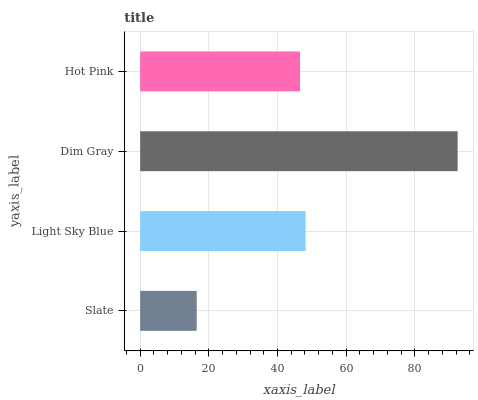Is Slate the minimum?
Answer yes or no. Yes. Is Dim Gray the maximum?
Answer yes or no. Yes. Is Light Sky Blue the minimum?
Answer yes or no. No. Is Light Sky Blue the maximum?
Answer yes or no. No. Is Light Sky Blue greater than Slate?
Answer yes or no. Yes. Is Slate less than Light Sky Blue?
Answer yes or no. Yes. Is Slate greater than Light Sky Blue?
Answer yes or no. No. Is Light Sky Blue less than Slate?
Answer yes or no. No. Is Light Sky Blue the high median?
Answer yes or no. Yes. Is Hot Pink the low median?
Answer yes or no. Yes. Is Dim Gray the high median?
Answer yes or no. No. Is Slate the low median?
Answer yes or no. No. 